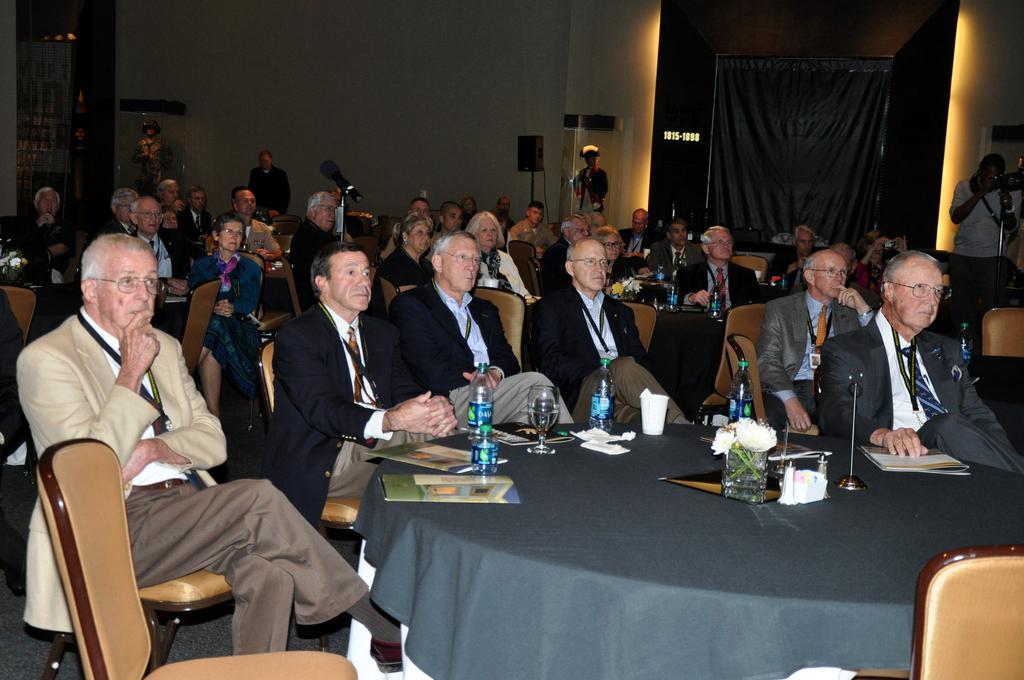Could you give a brief overview of what you see in this image? In this image I can see group of people sitting and four persons standing. There are chairs. There are water bottles, glasses, tissues and some other objects on the tables. Also there are walls, speakers and there is a curtain. 